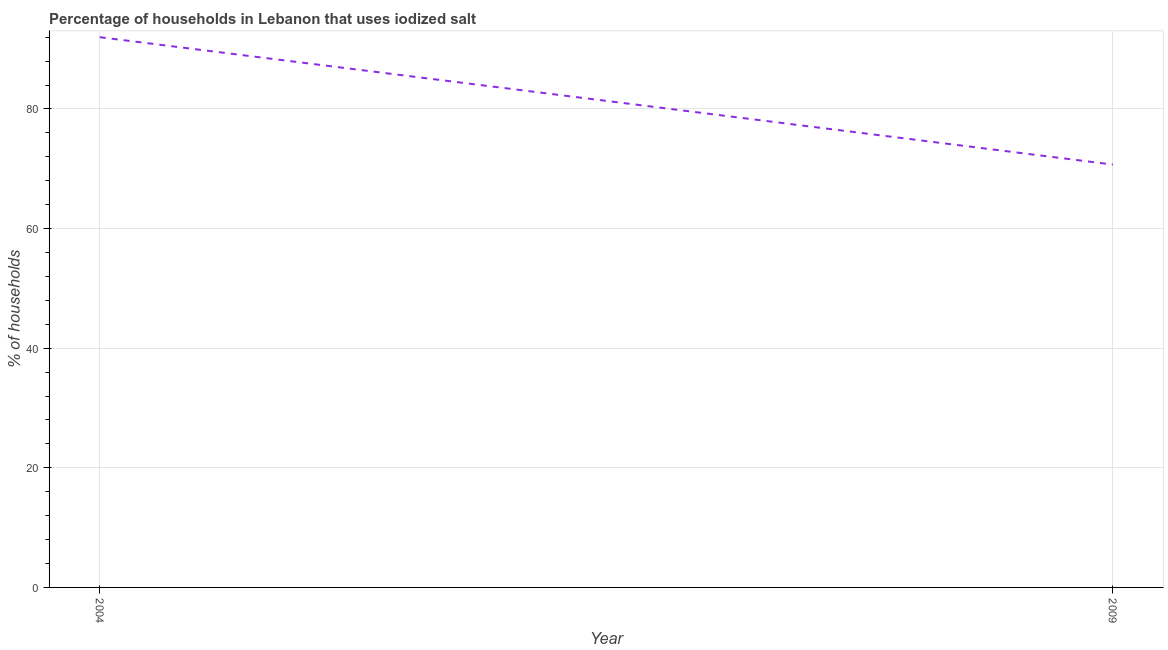What is the percentage of households where iodized salt is consumed in 2004?
Offer a terse response. 92. Across all years, what is the maximum percentage of households where iodized salt is consumed?
Offer a terse response. 92. Across all years, what is the minimum percentage of households where iodized salt is consumed?
Give a very brief answer. 70.7. In which year was the percentage of households where iodized salt is consumed maximum?
Your response must be concise. 2004. In which year was the percentage of households where iodized salt is consumed minimum?
Your answer should be very brief. 2009. What is the sum of the percentage of households where iodized salt is consumed?
Make the answer very short. 162.7. What is the difference between the percentage of households where iodized salt is consumed in 2004 and 2009?
Your answer should be very brief. 21.3. What is the average percentage of households where iodized salt is consumed per year?
Your answer should be very brief. 81.35. What is the median percentage of households where iodized salt is consumed?
Keep it short and to the point. 81.35. Do a majority of the years between 2009 and 2004 (inclusive) have percentage of households where iodized salt is consumed greater than 68 %?
Offer a very short reply. No. What is the ratio of the percentage of households where iodized salt is consumed in 2004 to that in 2009?
Make the answer very short. 1.3. In how many years, is the percentage of households where iodized salt is consumed greater than the average percentage of households where iodized salt is consumed taken over all years?
Provide a short and direct response. 1. Does the percentage of households where iodized salt is consumed monotonically increase over the years?
Offer a very short reply. No. How many lines are there?
Provide a succinct answer. 1. What is the difference between two consecutive major ticks on the Y-axis?
Provide a short and direct response. 20. What is the title of the graph?
Give a very brief answer. Percentage of households in Lebanon that uses iodized salt. What is the label or title of the Y-axis?
Offer a very short reply. % of households. What is the % of households in 2004?
Offer a terse response. 92. What is the % of households in 2009?
Make the answer very short. 70.7. What is the difference between the % of households in 2004 and 2009?
Provide a succinct answer. 21.3. What is the ratio of the % of households in 2004 to that in 2009?
Give a very brief answer. 1.3. 